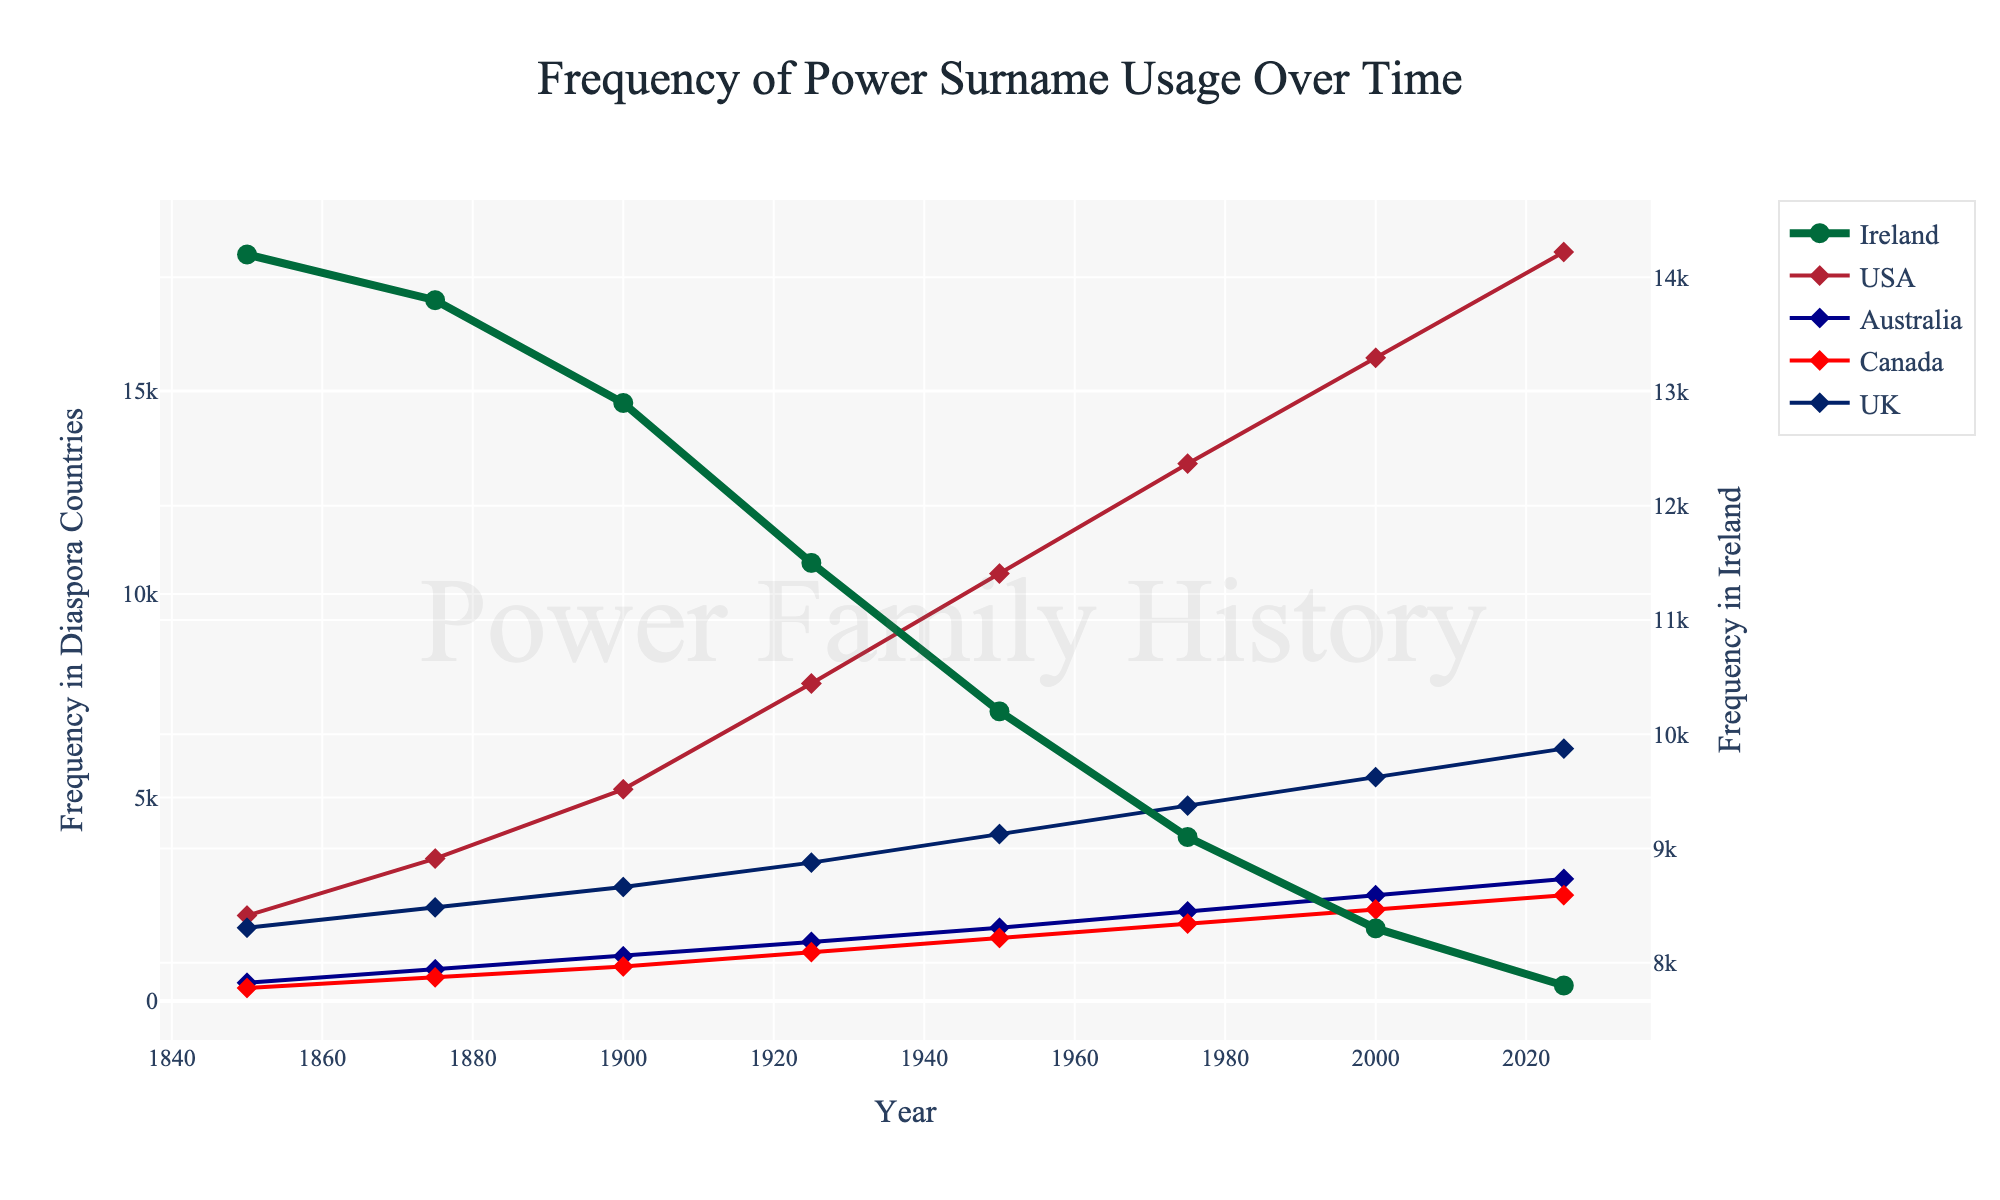what is the trend of the Power surname frequency in Ireland from 1850 to 2025? From 1850 to 2025, the frequency of the Power surname in Ireland is steadily decreasing. In 1850, it was about 14200, and by 2025 it dropped to around 7800. Each subsequent year shows a gradual decline
Answer: Steadily decreasing how does the frequency of Power surname usage in the USA in 2025 compare to that in Ireland in 2025? The frequency of the Power surname in the USA in 2025 is significantly higher than in Ireland. In 2025, the USA has about 18400 whereas Ireland has about 7800
Answer: Higher in the USA Calculate the total frequency of the Power surname in diaspora countries (USA, Australia, Canada, UK) in the year 1950 Summing the frequencies for the diaspora countries in 1950: USA (10500) + Australia (1800) + Canada (1550) + UK (4100) = 17950
Answer: 17950 What is the difference in the frequency of the Power surname between Canada and Australia in 1925? In 1925, the frequency in Canada is around 1200 and in Australia is around 1450. The difference is 1450 - 1200 = 250
Answer: 250 Between which years did the frequency of the Power surname in the USA see the most significant increase? The most significant increase in the USA is between 1925 (7800) and 1950 (10500), with an increase of 2700
Answer: 1925-1950 Compare the trend of the Power surname frequency from 1850 to 2025 in the UK and Ireland In both the UK and Ireland, the frequency of the Power surname shows a gradually decreasing trend. However, the decline in Ireland is more pronounced compared to the more gradual decline in the UK
Answer: Gradually decreasing in both; more pronounced in Ireland What is the visual relationship between the color used for Ireland and the other countries? The line for Ireland is thicker and uses a green color, with larger, circle markers, whereas other countries use thinner lines, different colors, and diamond-shaped markers
Answer: Thicker green line and circles for Ireland; different markers and thinner lines for others If you sum the frequencies of the Power surname in Ireland and UK in 1975, what is the result? Adding Ireland (9100) and UK (4800) frequencies in 1975 gives 9100 + 4800 = 13900
Answer: 13900 During which time period did the Power surname frequency in Australia have a steady upward trend? The frequency in Australia shows a consistent upward trend from 1900 (1100) to 2025 (3000), with data points regularly increasing over each subsequent period
Answer: 1900-2025 Which country had the highest frequency of the Power surname in 2000? In 2000, the USA has the highest frequency of the Power surname with a value of around 15800
Answer: USA 